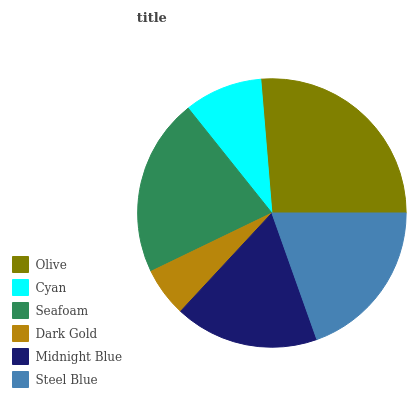Is Dark Gold the minimum?
Answer yes or no. Yes. Is Olive the maximum?
Answer yes or no. Yes. Is Cyan the minimum?
Answer yes or no. No. Is Cyan the maximum?
Answer yes or no. No. Is Olive greater than Cyan?
Answer yes or no. Yes. Is Cyan less than Olive?
Answer yes or no. Yes. Is Cyan greater than Olive?
Answer yes or no. No. Is Olive less than Cyan?
Answer yes or no. No. Is Steel Blue the high median?
Answer yes or no. Yes. Is Midnight Blue the low median?
Answer yes or no. Yes. Is Midnight Blue the high median?
Answer yes or no. No. Is Cyan the low median?
Answer yes or no. No. 